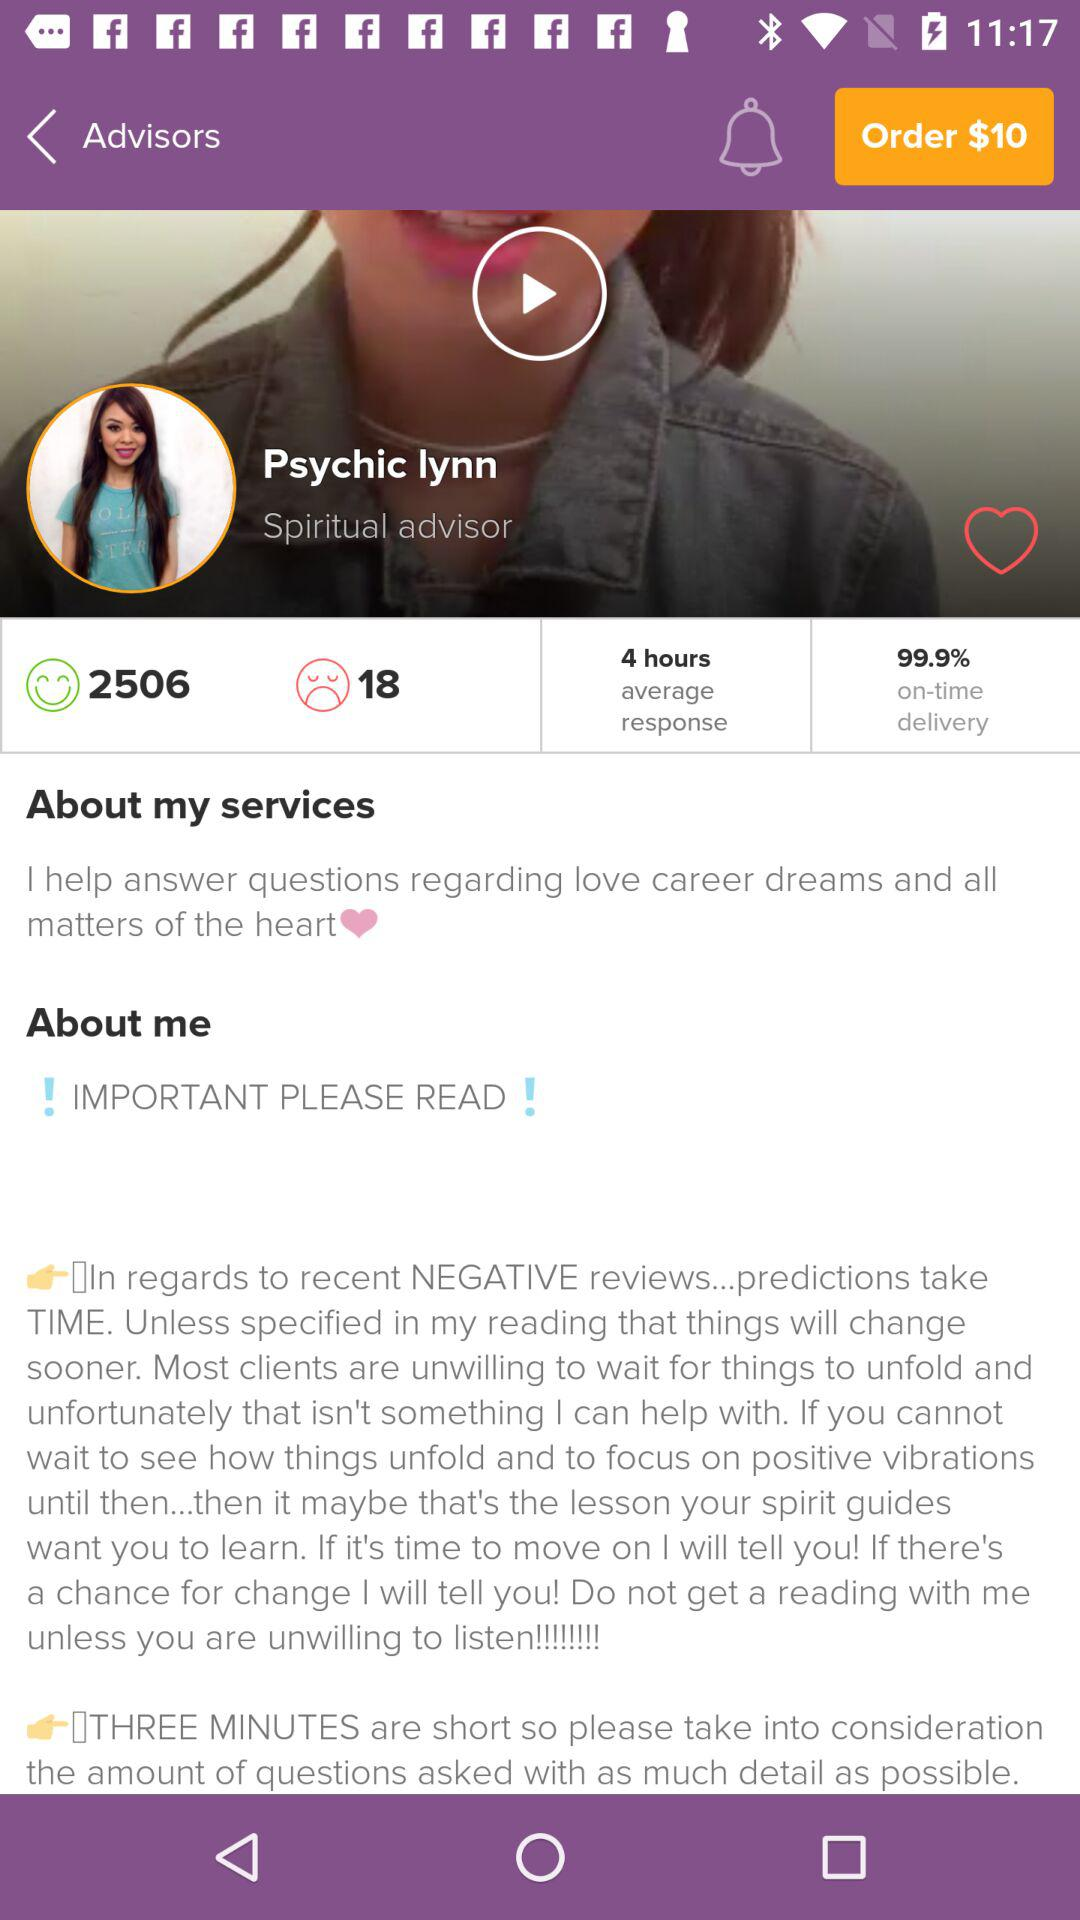What is the on-time delivery percentage? The on-time delivery percentage is 99.9. 